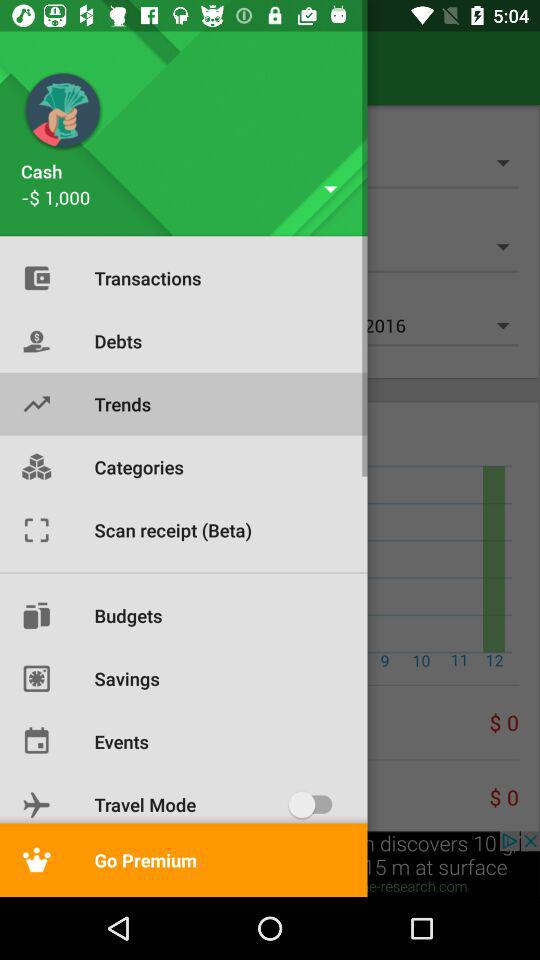What is the status of "Travel Mode"? The status of "Travel Mode" is "off". 